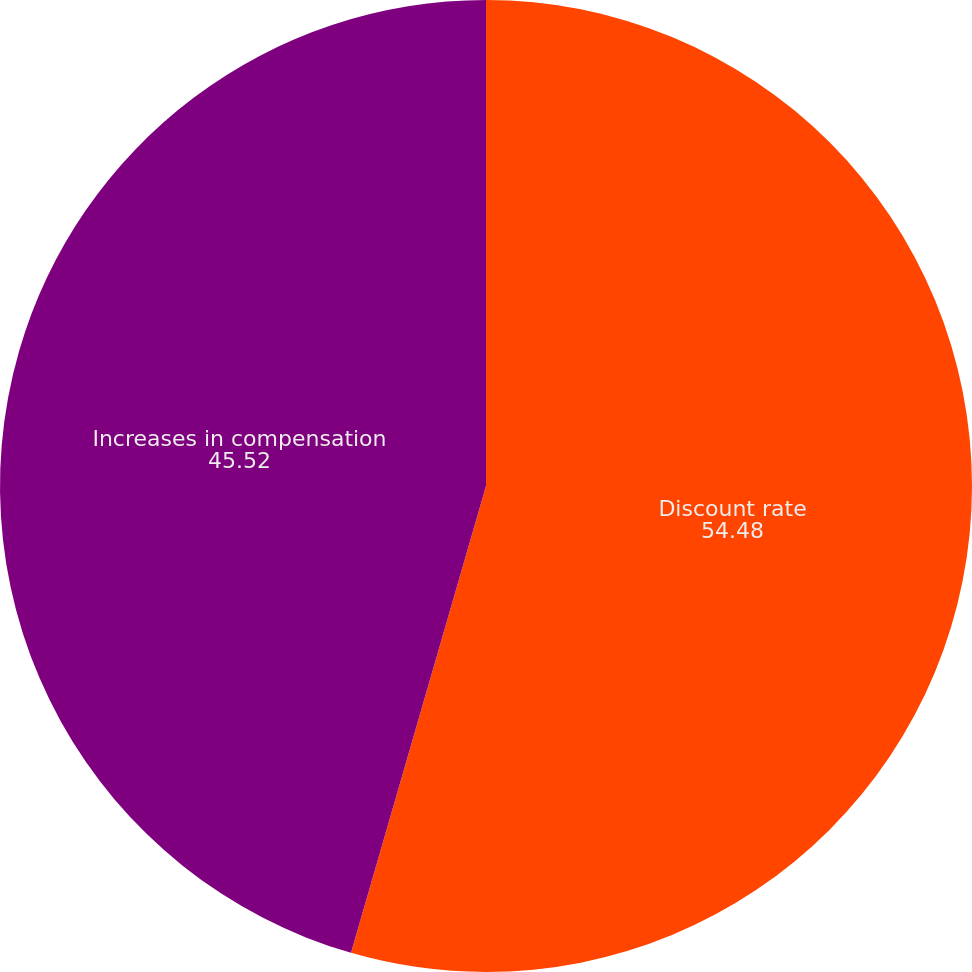<chart> <loc_0><loc_0><loc_500><loc_500><pie_chart><fcel>Discount rate<fcel>Increases in compensation<nl><fcel>54.48%<fcel>45.52%<nl></chart> 